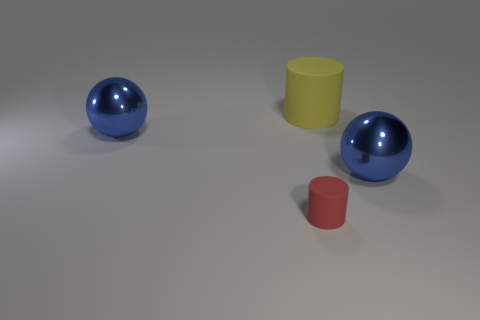What is the color of the cylinder behind the tiny matte thing that is in front of the large yellow cylinder?
Offer a terse response. Yellow. What size is the blue metallic ball in front of the blue shiny thing that is behind the large blue metallic thing that is right of the red matte object?
Make the answer very short. Large. Are there fewer red objects that are on the right side of the yellow thing than large yellow matte cylinders that are in front of the red rubber cylinder?
Your answer should be compact. No. How many tiny cylinders are made of the same material as the yellow object?
Offer a very short reply. 1. Is there a object that is in front of the big cylinder that is right of the blue sphere that is on the left side of the small object?
Your response must be concise. Yes. There is a tiny object that is the same material as the big yellow thing; what is its shape?
Your response must be concise. Cylinder. Are there more big shiny spheres than tiny blue cylinders?
Keep it short and to the point. Yes. There is a small matte object; does it have the same shape as the large metal thing that is to the right of the small red rubber cylinder?
Keep it short and to the point. No. What is the red thing made of?
Keep it short and to the point. Rubber. What color is the cylinder that is in front of the blue metal ball that is in front of the blue shiny thing that is left of the yellow matte cylinder?
Keep it short and to the point. Red. 